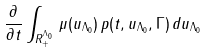<formula> <loc_0><loc_0><loc_500><loc_500>\frac { \partial } { { \partial } t } \int _ { { R } _ { + } ^ { \Lambda _ { 0 } } } \, \mu ( u _ { \Lambda _ { 0 } } ) \, p ( t , u _ { \Lambda _ { 0 } } , \Gamma ) \, d u _ { \Lambda _ { 0 } } \,</formula> 